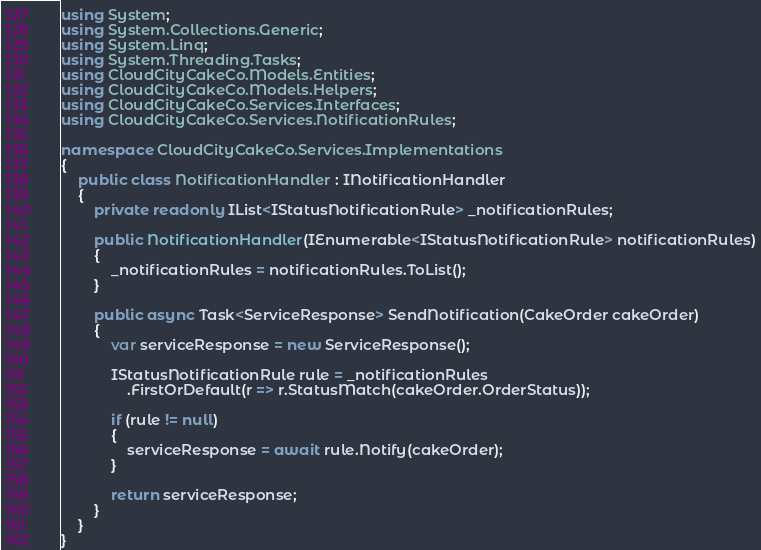<code> <loc_0><loc_0><loc_500><loc_500><_C#_>using System;
using System.Collections.Generic;
using System.Linq;
using System.Threading.Tasks;
using CloudCityCakeCo.Models.Entities;
using CloudCityCakeCo.Models.Helpers;
using CloudCityCakeCo.Services.Interfaces;
using CloudCityCakeCo.Services.NotificationRules;

namespace CloudCityCakeCo.Services.Implementations
{
    public class NotificationHandler : INotificationHandler
    {
        private readonly IList<IStatusNotificationRule> _notificationRules;

        public NotificationHandler(IEnumerable<IStatusNotificationRule> notificationRules)
        {
            _notificationRules = notificationRules.ToList();
        }
        
        public async Task<ServiceResponse> SendNotification(CakeOrder cakeOrder)
        {
            var serviceResponse = new ServiceResponse();

            IStatusNotificationRule rule = _notificationRules
                .FirstOrDefault(r => r.StatusMatch(cakeOrder.OrderStatus));

            if (rule != null)
            {
                serviceResponse = await rule.Notify(cakeOrder);
            }

            return serviceResponse;
        }
    }
}</code> 